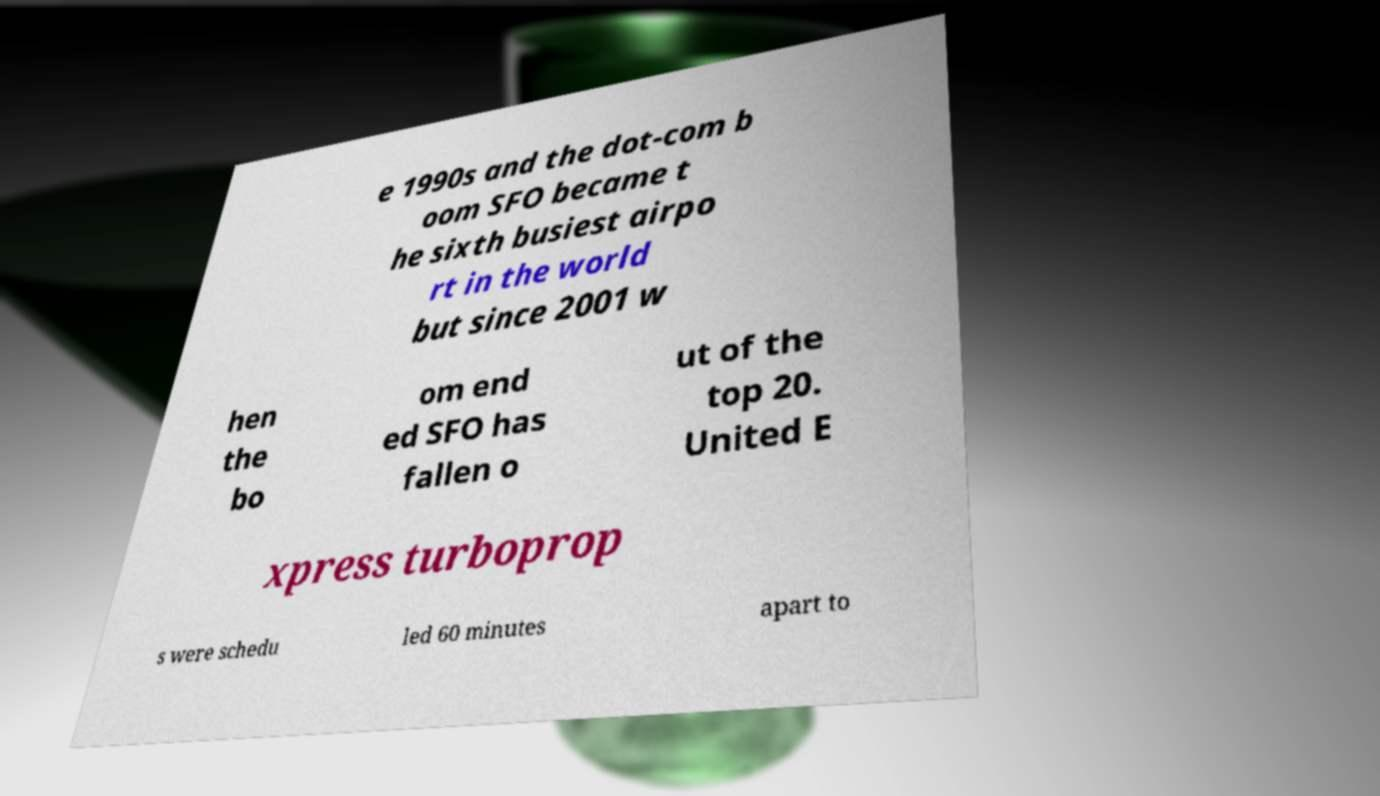There's text embedded in this image that I need extracted. Can you transcribe it verbatim? e 1990s and the dot-com b oom SFO became t he sixth busiest airpo rt in the world but since 2001 w hen the bo om end ed SFO has fallen o ut of the top 20. United E xpress turboprop s were schedu led 60 minutes apart to 